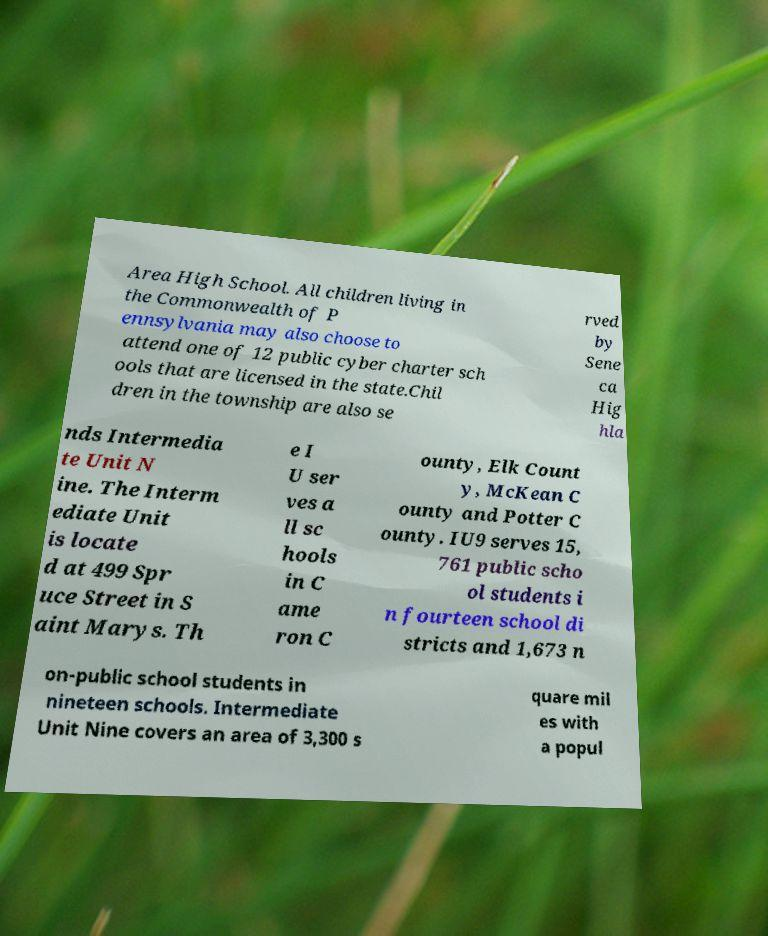Can you read and provide the text displayed in the image?This photo seems to have some interesting text. Can you extract and type it out for me? Area High School. All children living in the Commonwealth of P ennsylvania may also choose to attend one of 12 public cyber charter sch ools that are licensed in the state.Chil dren in the township are also se rved by Sene ca Hig hla nds Intermedia te Unit N ine. The Interm ediate Unit is locate d at 499 Spr uce Street in S aint Marys. Th e I U ser ves a ll sc hools in C ame ron C ounty, Elk Count y, McKean C ounty and Potter C ounty. IU9 serves 15, 761 public scho ol students i n fourteen school di stricts and 1,673 n on-public school students in nineteen schools. Intermediate Unit Nine covers an area of 3,300 s quare mil es with a popul 